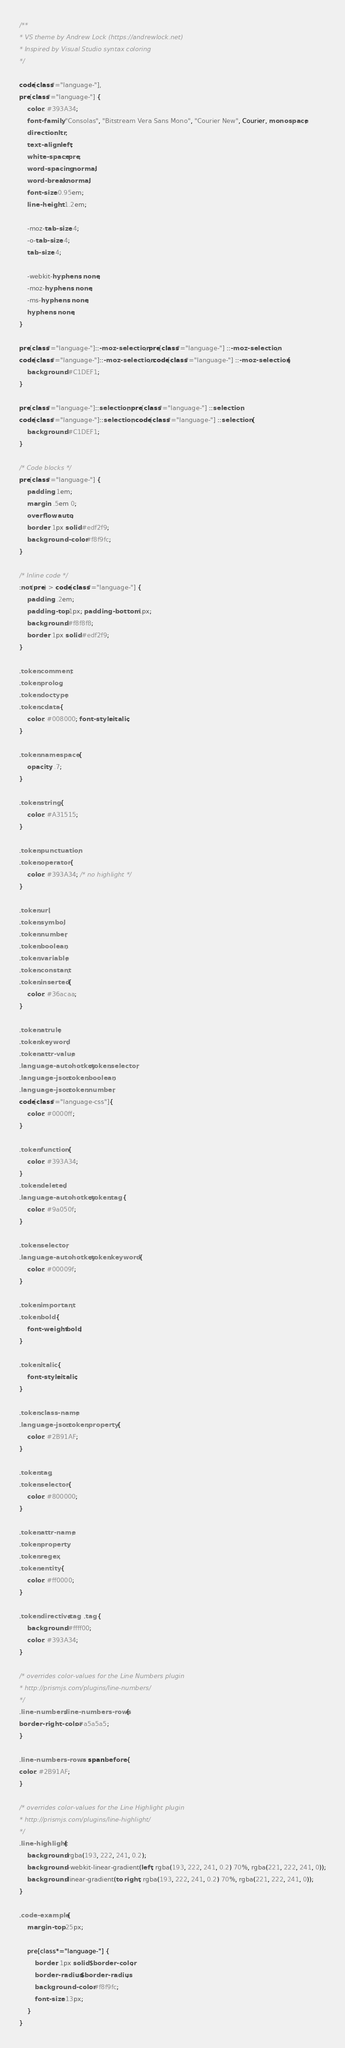<code> <loc_0><loc_0><loc_500><loc_500><_CSS_>/**
* VS theme by Andrew Lock (https://andrewlock.net)
* Inspired by Visual Studio syntax coloring
*/

code[class*="language-"],
pre[class*="language-"] {
    color: #393A34;
    font-family: "Consolas", "Bitstream Vera Sans Mono", "Courier New", Courier, monospace;
    direction: ltr;
    text-align: left;
    white-space: pre;
    word-spacing: normal;
    word-break: normal;
    font-size: 0.95em;
    line-height: 1.2em;

    -moz-tab-size: 4;
    -o-tab-size: 4;
    tab-size: 4;

    -webkit-hyphens: none;
    -moz-hyphens: none;
    -ms-hyphens: none;
    hyphens: none;
}

pre[class*="language-"]::-moz-selection, pre[class*="language-"] ::-moz-selection,
code[class*="language-"]::-moz-selection, code[class*="language-"] ::-moz-selection {
    background: #C1DEF1;
}

pre[class*="language-"]::selection, pre[class*="language-"] ::selection,
code[class*="language-"]::selection, code[class*="language-"] ::selection {
    background: #C1DEF1;
}

/* Code blocks */
pre[class*="language-"] {
    padding: 1em;
    margin: .5em 0;
    overflow: auto;
    border: 1px solid #edf2f9;
    background-color: #f8f9fc;
}

/* Inline code */
:not(pre) > code[class*="language-"] {
    padding: .2em;
    padding-top: 1px; padding-bottom: 1px;
    background: #f8f8f8;
    border: 1px solid #edf2f9;
}

.token.comment,
.token.prolog,
.token.doctype,
.token.cdata {
    color: #008000; font-style: italic;
}

.token.namespace {
    opacity: .7;
}

.token.string {
    color: #A31515;
}

.token.punctuation,
.token.operator {
    color: #393A34; /* no highlight */
}

.token.url,
.token.symbol,
.token.number,
.token.boolean,
.token.variable,
.token.constant,
.token.inserted {
    color: #36acaa;
}

.token.atrule,
.token.keyword,
.token.attr-value,
.language-autohotkey .token.selector,
.language-json .token.boolean, 
.language-json .token.number, 
code[class*="language-css"]{
    color: #0000ff;
}

.token.function {
    color: #393A34;
}
.token.deleted,
.language-autohotkey .token.tag {
    color: #9a050f;
}

.token.selector,
.language-autohotkey .token.keyword {
    color: #00009f;
}

.token.important,
.token.bold {
    font-weight: bold;
}

.token.italic {
    font-style: italic;
}

.token.class-name,
.language-json .token.property {
    color: #2B91AF;
}

.token.tag,
.token.selector {
    color: #800000;
}

.token.attr-name,
.token.property,
.token.regex,
.token.entity {
    color: #ff0000;
}

.token.directive.tag  .tag {
    background: #ffff00;
    color: #393A34;
}

/* overrides color-values for the Line Numbers plugin
* http://prismjs.com/plugins/line-numbers/
*/
.line-numbers .line-numbers-rows {
border-right-color: #a5a5a5;
}

.line-numbers-rows > span:before {
color: #2B91AF;
}

/* overrides color-values for the Line Highlight plugin
* http://prismjs.com/plugins/line-highlight/
*/
.line-highlight {
    background: rgba(193, 222, 241, 0.2);
    background: -webkit-linear-gradient(left, rgba(193, 222, 241, 0.2) 70%, rgba(221, 222, 241, 0));
    background: linear-gradient(to right, rgba(193, 222, 241, 0.2) 70%, rgba(221, 222, 241, 0));
}

.code-example {
    margin-top: 25px;

    pre[class*="language-"] {
        border: 1px solid $border-color;
        border-radius: $border-radius;
        background-color: #f8f9fc;
        font-size: 13px;
    }
}</code> 